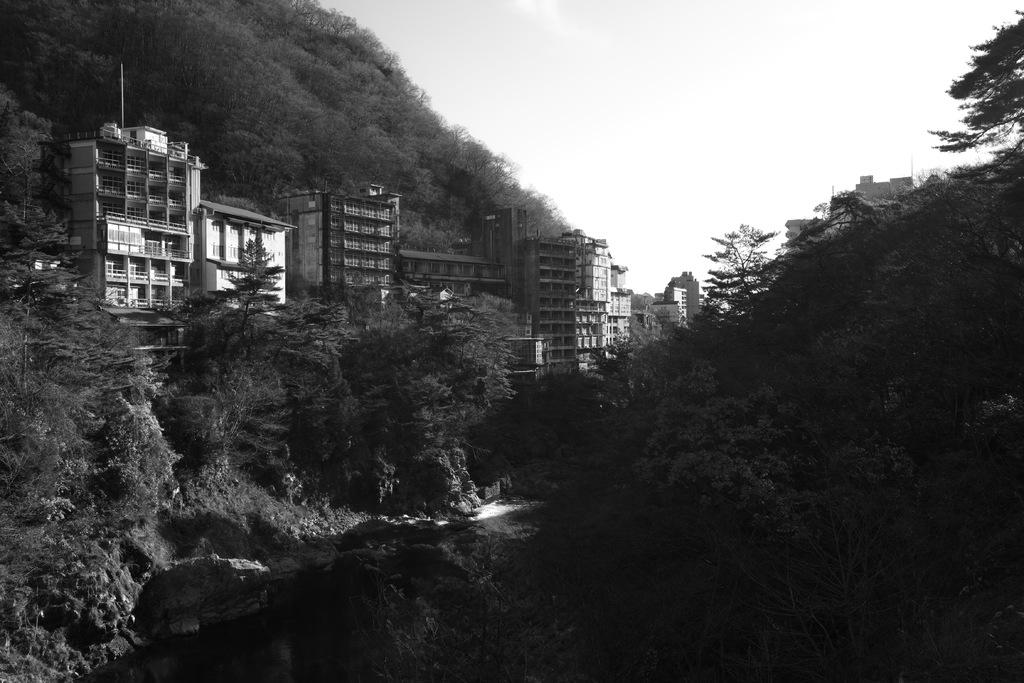What is the color scheme of the image? The image is black and white. What type of natural elements can be seen in the image? There are trees in the image. What type of man-made structures are present in the image? There are buildings in the image. What is visible in the background of the image? The sky is visible in the background of the image. What type of marble can be seen on the ground in the image? There is no marble present in the image; it is a black and white image with trees, buildings, and a visible sky. 